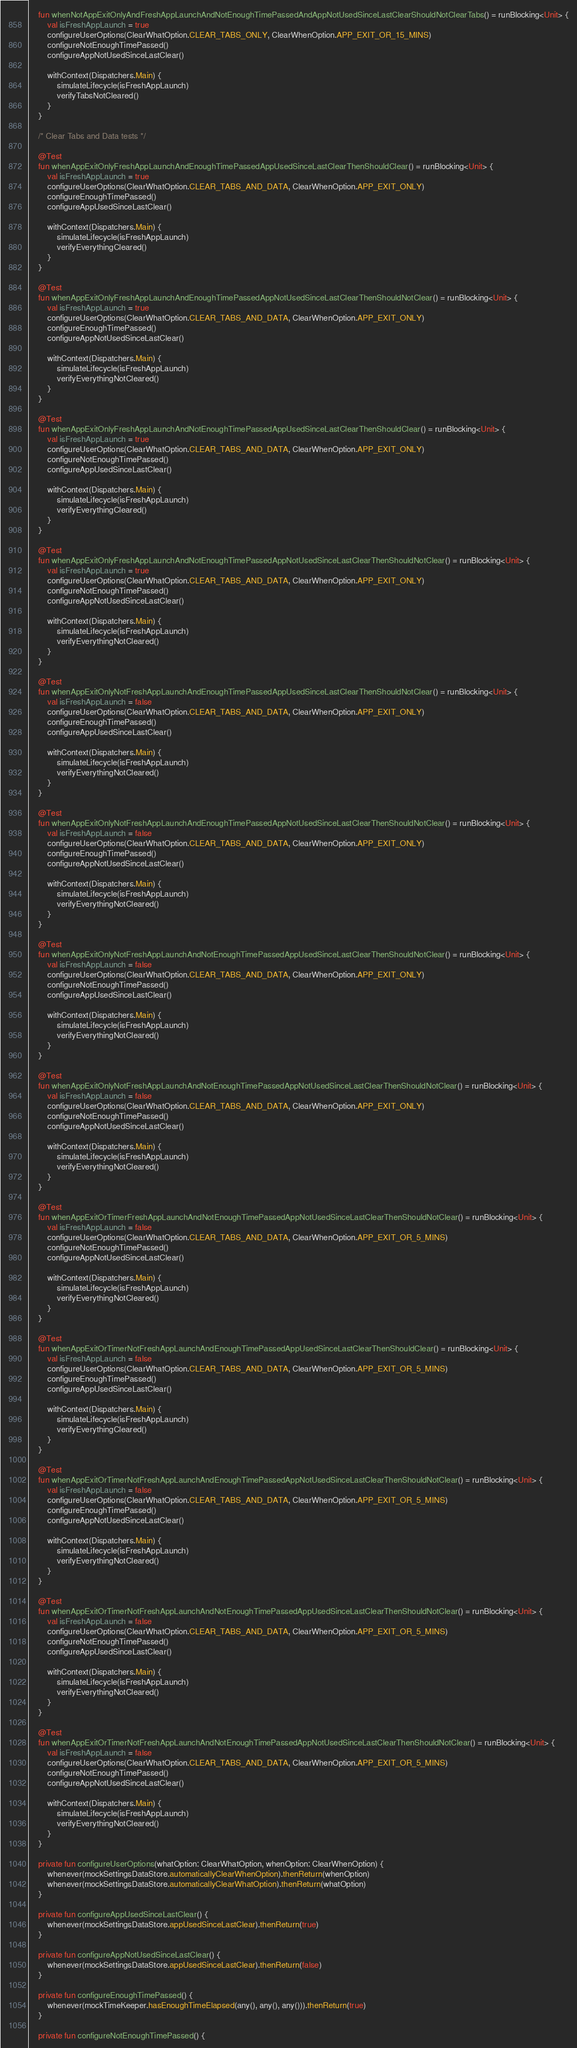Convert code to text. <code><loc_0><loc_0><loc_500><loc_500><_Kotlin_>    fun whenNotAppExitOnlyAndFreshAppLaunchAndNotEnoughTimePassedAndAppNotUsedSinceLastClearShouldNotClearTabs() = runBlocking<Unit> {
        val isFreshAppLaunch = true
        configureUserOptions(ClearWhatOption.CLEAR_TABS_ONLY, ClearWhenOption.APP_EXIT_OR_15_MINS)
        configureNotEnoughTimePassed()
        configureAppNotUsedSinceLastClear()

        withContext(Dispatchers.Main) {
            simulateLifecycle(isFreshAppLaunch)
            verifyTabsNotCleared()
        }
    }

    /* Clear Tabs and Data tests */

    @Test
    fun whenAppExitOnlyFreshAppLaunchAndEnoughTimePassedAppUsedSinceLastClearThenShouldClear() = runBlocking<Unit> {
        val isFreshAppLaunch = true
        configureUserOptions(ClearWhatOption.CLEAR_TABS_AND_DATA, ClearWhenOption.APP_EXIT_ONLY)
        configureEnoughTimePassed()
        configureAppUsedSinceLastClear()

        withContext(Dispatchers.Main) {
            simulateLifecycle(isFreshAppLaunch)
            verifyEverythingCleared()
        }
    }

    @Test
    fun whenAppExitOnlyFreshAppLaunchAndEnoughTimePassedAppNotUsedSinceLastClearThenShouldNotClear() = runBlocking<Unit> {
        val isFreshAppLaunch = true
        configureUserOptions(ClearWhatOption.CLEAR_TABS_AND_DATA, ClearWhenOption.APP_EXIT_ONLY)
        configureEnoughTimePassed()
        configureAppNotUsedSinceLastClear()

        withContext(Dispatchers.Main) {
            simulateLifecycle(isFreshAppLaunch)
            verifyEverythingNotCleared()
        }
    }

    @Test
    fun whenAppExitOnlyFreshAppLaunchAndNotEnoughTimePassedAppUsedSinceLastClearThenShouldClear() = runBlocking<Unit> {
        val isFreshAppLaunch = true
        configureUserOptions(ClearWhatOption.CLEAR_TABS_AND_DATA, ClearWhenOption.APP_EXIT_ONLY)
        configureNotEnoughTimePassed()
        configureAppUsedSinceLastClear()

        withContext(Dispatchers.Main) {
            simulateLifecycle(isFreshAppLaunch)
            verifyEverythingCleared()
        }
    }

    @Test
    fun whenAppExitOnlyFreshAppLaunchAndNotEnoughTimePassedAppNotUsedSinceLastClearThenShouldNotClear() = runBlocking<Unit> {
        val isFreshAppLaunch = true
        configureUserOptions(ClearWhatOption.CLEAR_TABS_AND_DATA, ClearWhenOption.APP_EXIT_ONLY)
        configureNotEnoughTimePassed()
        configureAppNotUsedSinceLastClear()

        withContext(Dispatchers.Main) {
            simulateLifecycle(isFreshAppLaunch)
            verifyEverythingNotCleared()
        }
    }

    @Test
    fun whenAppExitOnlyNotFreshAppLaunchAndEnoughTimePassedAppUsedSinceLastClearThenShouldNotClear() = runBlocking<Unit> {
        val isFreshAppLaunch = false
        configureUserOptions(ClearWhatOption.CLEAR_TABS_AND_DATA, ClearWhenOption.APP_EXIT_ONLY)
        configureEnoughTimePassed()
        configureAppUsedSinceLastClear()

        withContext(Dispatchers.Main) {
            simulateLifecycle(isFreshAppLaunch)
            verifyEverythingNotCleared()
        }
    }

    @Test
    fun whenAppExitOnlyNotFreshAppLaunchAndEnoughTimePassedAppNotUsedSinceLastClearThenShouldNotClear() = runBlocking<Unit> {
        val isFreshAppLaunch = false
        configureUserOptions(ClearWhatOption.CLEAR_TABS_AND_DATA, ClearWhenOption.APP_EXIT_ONLY)
        configureEnoughTimePassed()
        configureAppNotUsedSinceLastClear()

        withContext(Dispatchers.Main) {
            simulateLifecycle(isFreshAppLaunch)
            verifyEverythingNotCleared()
        }
    }

    @Test
    fun whenAppExitOnlyNotFreshAppLaunchAndNotEnoughTimePassedAppUsedSinceLastClearThenShouldNotClear() = runBlocking<Unit> {
        val isFreshAppLaunch = false
        configureUserOptions(ClearWhatOption.CLEAR_TABS_AND_DATA, ClearWhenOption.APP_EXIT_ONLY)
        configureNotEnoughTimePassed()
        configureAppUsedSinceLastClear()

        withContext(Dispatchers.Main) {
            simulateLifecycle(isFreshAppLaunch)
            verifyEverythingNotCleared()
        }
    }

    @Test
    fun whenAppExitOnlyNotFreshAppLaunchAndNotEnoughTimePassedAppNotUsedSinceLastClearThenShouldNotClear() = runBlocking<Unit> {
        val isFreshAppLaunch = false
        configureUserOptions(ClearWhatOption.CLEAR_TABS_AND_DATA, ClearWhenOption.APP_EXIT_ONLY)
        configureNotEnoughTimePassed()
        configureAppNotUsedSinceLastClear()

        withContext(Dispatchers.Main) {
            simulateLifecycle(isFreshAppLaunch)
            verifyEverythingNotCleared()
        }
    }

    @Test
    fun whenAppExitOrTimerFreshAppLaunchAndNotEnoughTimePassedAppNotUsedSinceLastClearThenShouldNotClear() = runBlocking<Unit> {
        val isFreshAppLaunch = false
        configureUserOptions(ClearWhatOption.CLEAR_TABS_AND_DATA, ClearWhenOption.APP_EXIT_OR_5_MINS)
        configureNotEnoughTimePassed()
        configureAppNotUsedSinceLastClear()

        withContext(Dispatchers.Main) {
            simulateLifecycle(isFreshAppLaunch)
            verifyEverythingNotCleared()
        }
    }

    @Test
    fun whenAppExitOrTimerNotFreshAppLaunchAndEnoughTimePassedAppUsedSinceLastClearThenShouldClear() = runBlocking<Unit> {
        val isFreshAppLaunch = false
        configureUserOptions(ClearWhatOption.CLEAR_TABS_AND_DATA, ClearWhenOption.APP_EXIT_OR_5_MINS)
        configureEnoughTimePassed()
        configureAppUsedSinceLastClear()

        withContext(Dispatchers.Main) {
            simulateLifecycle(isFreshAppLaunch)
            verifyEverythingCleared()
        }
    }

    @Test
    fun whenAppExitOrTimerNotFreshAppLaunchAndEnoughTimePassedAppNotUsedSinceLastClearThenShouldNotClear() = runBlocking<Unit> {
        val isFreshAppLaunch = false
        configureUserOptions(ClearWhatOption.CLEAR_TABS_AND_DATA, ClearWhenOption.APP_EXIT_OR_5_MINS)
        configureEnoughTimePassed()
        configureAppNotUsedSinceLastClear()

        withContext(Dispatchers.Main) {
            simulateLifecycle(isFreshAppLaunch)
            verifyEverythingNotCleared()
        }
    }

    @Test
    fun whenAppExitOrTimerNotFreshAppLaunchAndNotEnoughTimePassedAppUsedSinceLastClearThenShouldNotClear() = runBlocking<Unit> {
        val isFreshAppLaunch = false
        configureUserOptions(ClearWhatOption.CLEAR_TABS_AND_DATA, ClearWhenOption.APP_EXIT_OR_5_MINS)
        configureNotEnoughTimePassed()
        configureAppUsedSinceLastClear()

        withContext(Dispatchers.Main) {
            simulateLifecycle(isFreshAppLaunch)
            verifyEverythingNotCleared()
        }
    }

    @Test
    fun whenAppExitOrTimerNotFreshAppLaunchAndNotEnoughTimePassedAppNotUsedSinceLastClearThenShouldNotClear() = runBlocking<Unit> {
        val isFreshAppLaunch = false
        configureUserOptions(ClearWhatOption.CLEAR_TABS_AND_DATA, ClearWhenOption.APP_EXIT_OR_5_MINS)
        configureNotEnoughTimePassed()
        configureAppNotUsedSinceLastClear()

        withContext(Dispatchers.Main) {
            simulateLifecycle(isFreshAppLaunch)
            verifyEverythingNotCleared()
        }
    }

    private fun configureUserOptions(whatOption: ClearWhatOption, whenOption: ClearWhenOption) {
        whenever(mockSettingsDataStore.automaticallyClearWhenOption).thenReturn(whenOption)
        whenever(mockSettingsDataStore.automaticallyClearWhatOption).thenReturn(whatOption)
    }

    private fun configureAppUsedSinceLastClear() {
        whenever(mockSettingsDataStore.appUsedSinceLastClear).thenReturn(true)
    }

    private fun configureAppNotUsedSinceLastClear() {
        whenever(mockSettingsDataStore.appUsedSinceLastClear).thenReturn(false)
    }

    private fun configureEnoughTimePassed() {
        whenever(mockTimeKeeper.hasEnoughTimeElapsed(any(), any(), any())).thenReturn(true)
    }

    private fun configureNotEnoughTimePassed() {</code> 